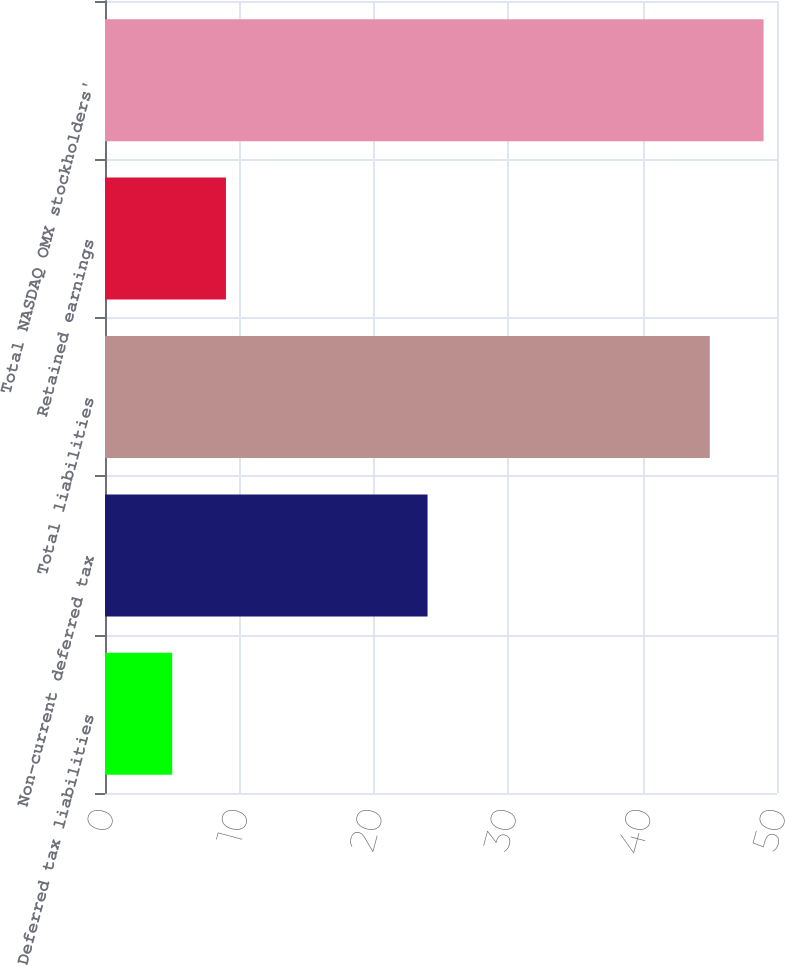Convert chart. <chart><loc_0><loc_0><loc_500><loc_500><bar_chart><fcel>Deferred tax liabilities<fcel>Non-current deferred tax<fcel>Total liabilities<fcel>Retained earnings<fcel>Total NASDAQ OMX stockholders'<nl><fcel>5<fcel>24<fcel>45<fcel>9<fcel>49<nl></chart> 